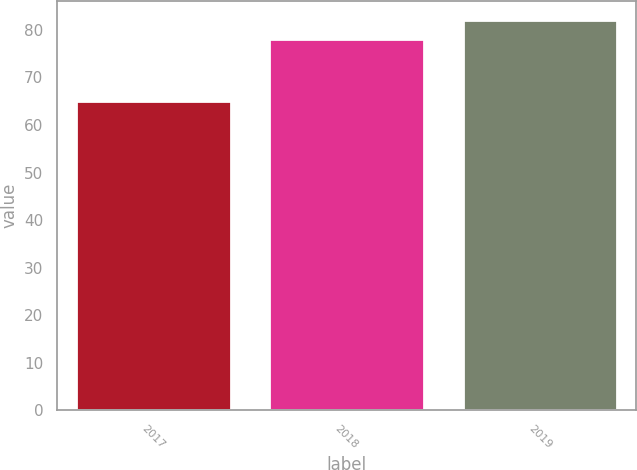Convert chart to OTSL. <chart><loc_0><loc_0><loc_500><loc_500><bar_chart><fcel>2017<fcel>2018<fcel>2019<nl><fcel>65<fcel>78<fcel>82<nl></chart> 